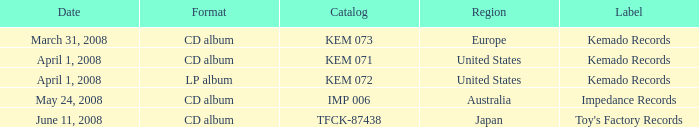Which Format has a Date of may 24, 2008? CD album. 